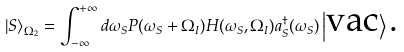<formula> <loc_0><loc_0><loc_500><loc_500>\left | S \right \rangle _ { \Omega _ { 2 } } = \int _ { - \infty } ^ { + \infty } d \omega _ { S } P ( \omega _ { S } + \Omega _ { I } ) H ( \omega _ { S } , \Omega _ { I } ) a _ { S } ^ { \dag } ( \omega _ { S } ) \left | \text {vac} \right \rangle \text {.}</formula> 